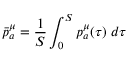Convert formula to latex. <formula><loc_0><loc_0><loc_500><loc_500>\bar { p } _ { a } ^ { \mu } = \frac { 1 } { S } \int _ { 0 } ^ { S } p _ { a } ^ { \mu } ( \tau ) \, d \tau</formula> 